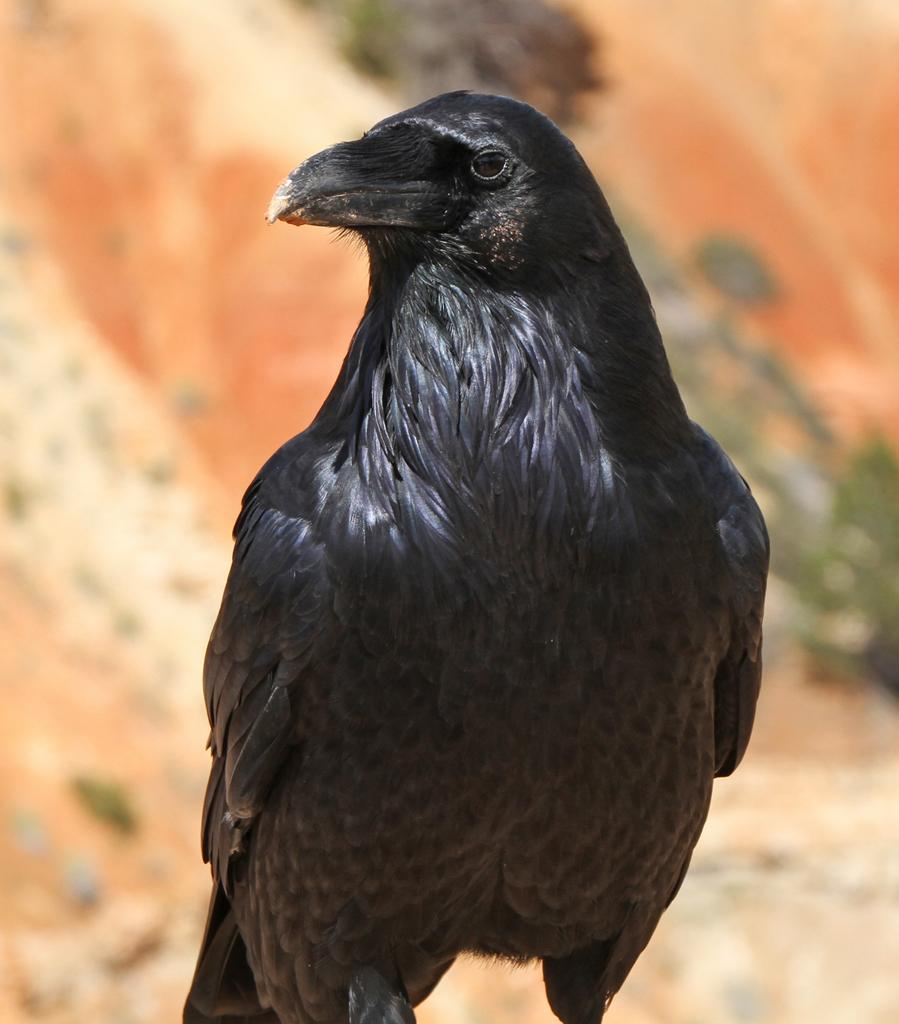What type of bird is in the image? There is a crow in the image. What color is the crow? The crow is black in color. Can you describe the background of the image? The background of the image appears blurry. What type of silver object can be seen in the image? There is no silver object present in the image; it only features a black crow against a blurry background. 